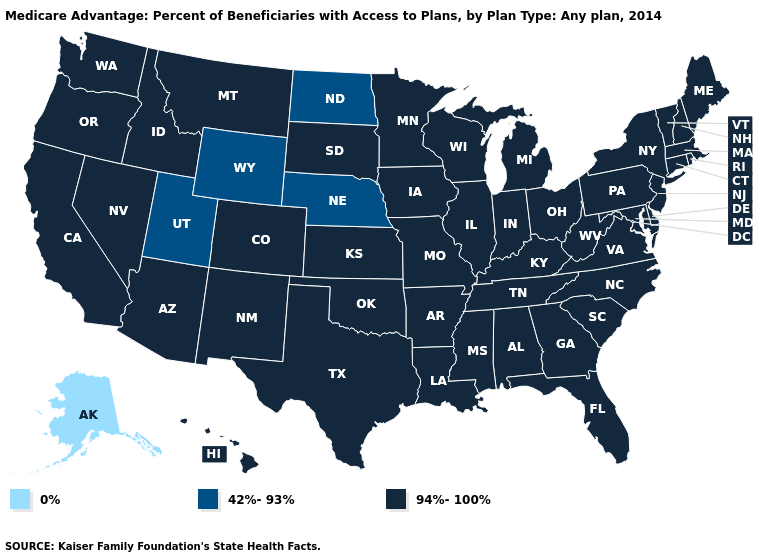Is the legend a continuous bar?
Keep it brief. No. Name the states that have a value in the range 42%-93%?
Concise answer only. North Dakota, Nebraska, Utah, Wyoming. What is the lowest value in states that border New York?
Give a very brief answer. 94%-100%. Which states hav the highest value in the MidWest?
Concise answer only. Iowa, Illinois, Indiana, Kansas, Michigan, Minnesota, Missouri, Ohio, South Dakota, Wisconsin. Name the states that have a value in the range 42%-93%?
Answer briefly. North Dakota, Nebraska, Utah, Wyoming. Does North Dakota have the highest value in the USA?
Short answer required. No. Name the states that have a value in the range 42%-93%?
Quick response, please. North Dakota, Nebraska, Utah, Wyoming. Which states hav the highest value in the West?
Concise answer only. California, Colorado, Hawaii, Idaho, Montana, New Mexico, Nevada, Oregon, Washington, Arizona. What is the value of Tennessee?
Be succinct. 94%-100%. Which states hav the highest value in the MidWest?
Answer briefly. Iowa, Illinois, Indiana, Kansas, Michigan, Minnesota, Missouri, Ohio, South Dakota, Wisconsin. Name the states that have a value in the range 94%-100%?
Keep it brief. California, Colorado, Connecticut, Delaware, Florida, Georgia, Hawaii, Iowa, Idaho, Illinois, Indiana, Kansas, Kentucky, Louisiana, Massachusetts, Maryland, Maine, Michigan, Minnesota, Missouri, Mississippi, Montana, North Carolina, New Hampshire, New Jersey, New Mexico, Nevada, New York, Ohio, Oklahoma, Oregon, Pennsylvania, Rhode Island, South Carolina, South Dakota, Tennessee, Texas, Virginia, Vermont, Washington, Wisconsin, West Virginia, Alabama, Arkansas, Arizona. Which states have the lowest value in the Northeast?
Write a very short answer. Connecticut, Massachusetts, Maine, New Hampshire, New Jersey, New York, Pennsylvania, Rhode Island, Vermont. What is the lowest value in states that border Louisiana?
Be succinct. 94%-100%. How many symbols are there in the legend?
Short answer required. 3. 